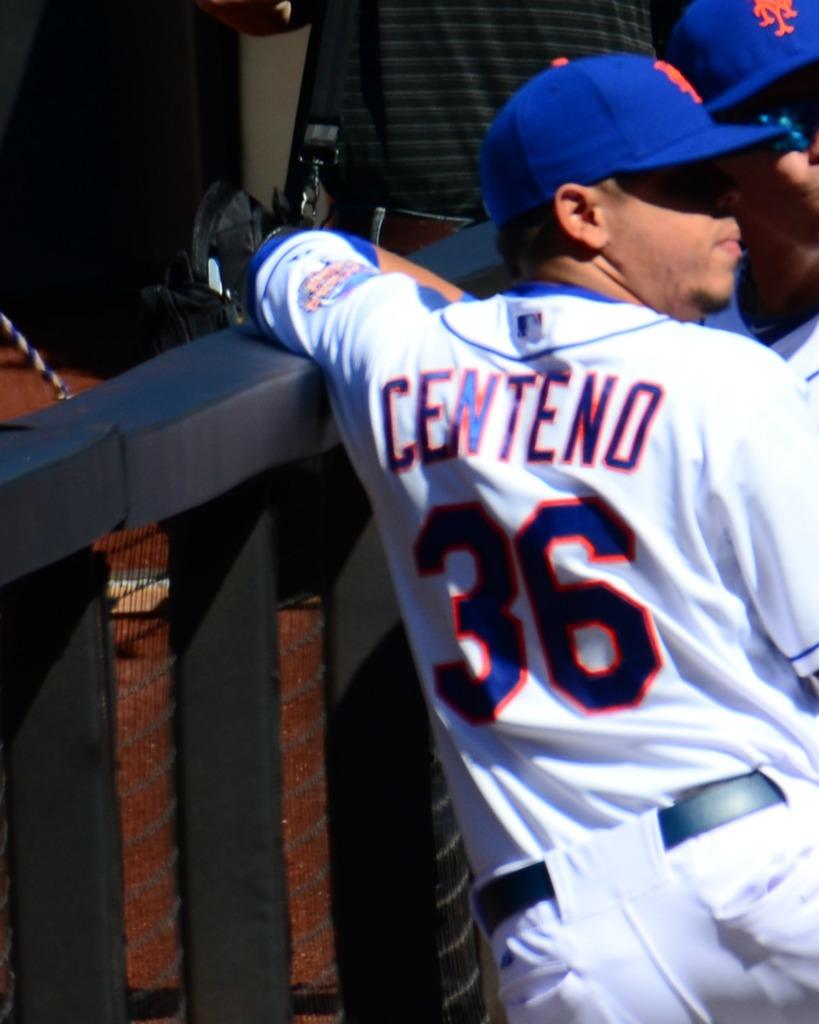What number is centeno?
Keep it short and to the point. 36. What is centeno's player number?
Make the answer very short. 36. 